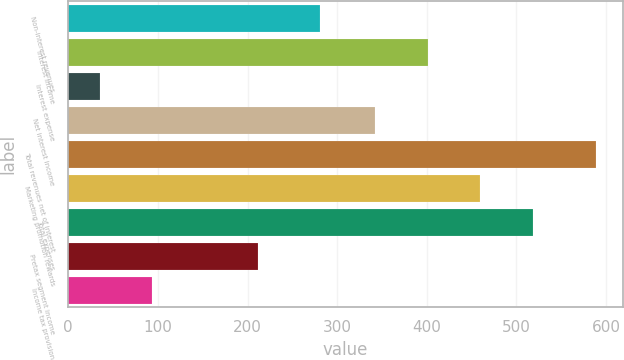<chart> <loc_0><loc_0><loc_500><loc_500><bar_chart><fcel>Non-interest revenues<fcel>Interest income<fcel>Interest expense<fcel>Net interest income<fcel>Total revenues net of interest<fcel>Marketing promotion rewards<fcel>Total expenses<fcel>Pretax segment income<fcel>Income tax provision<nl><fcel>281<fcel>400.8<fcel>35<fcel>342<fcel>589<fcel>459.6<fcel>518.4<fcel>211.4<fcel>93.8<nl></chart> 